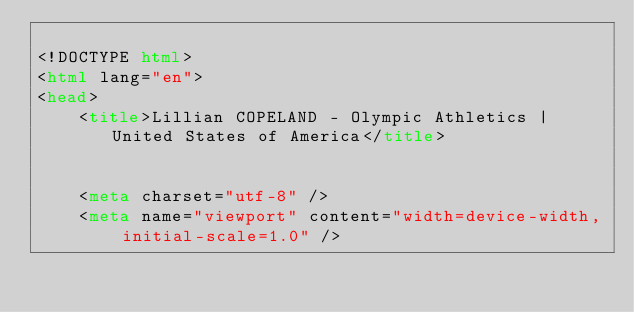<code> <loc_0><loc_0><loc_500><loc_500><_HTML_>
<!DOCTYPE html>
<html lang="en">
<head>
    <title>Lillian COPELAND - Olympic Athletics | United States of America</title>

    
    <meta charset="utf-8" />
    <meta name="viewport" content="width=device-width, initial-scale=1.0" /></code> 